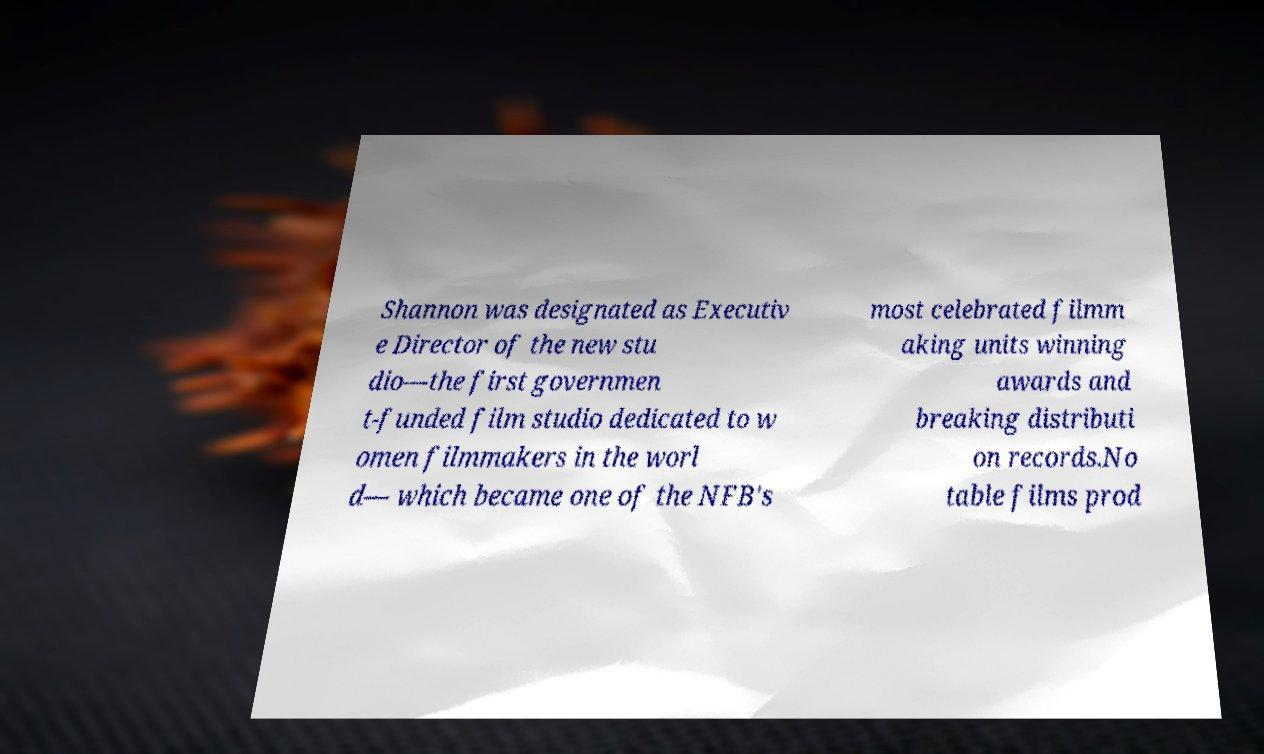Can you accurately transcribe the text from the provided image for me? Shannon was designated as Executiv e Director of the new stu dio—the first governmen t-funded film studio dedicated to w omen filmmakers in the worl d— which became one of the NFB's most celebrated filmm aking units winning awards and breaking distributi on records.No table films prod 